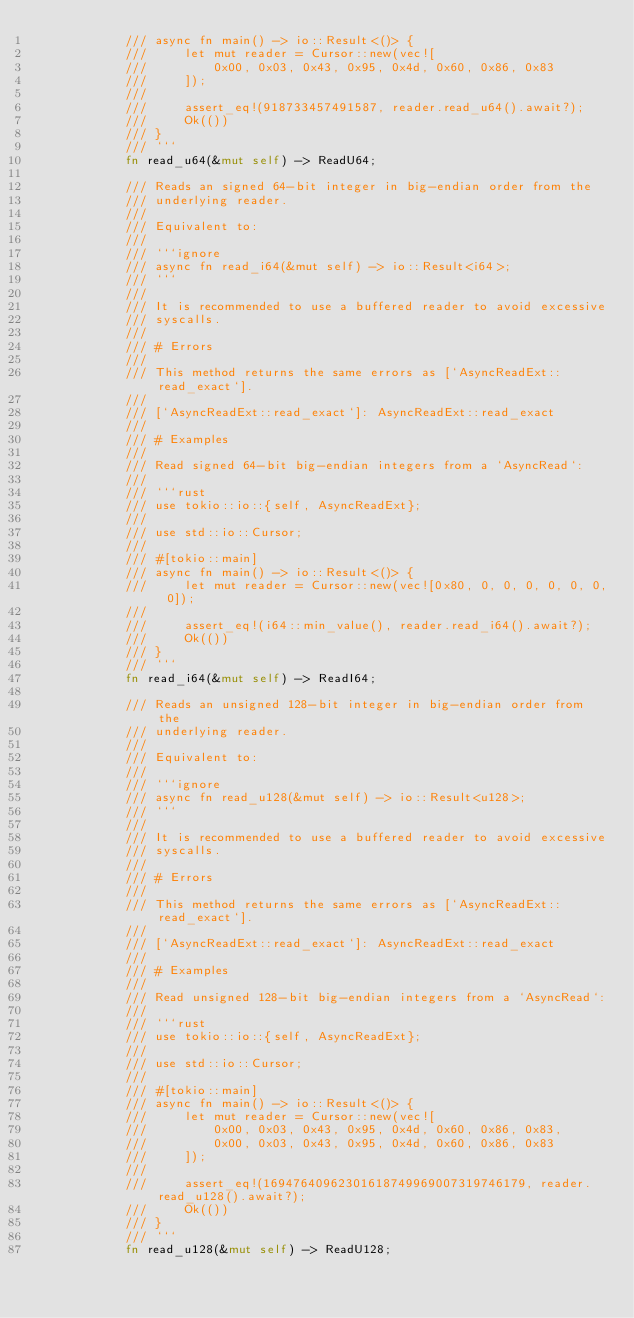Convert code to text. <code><loc_0><loc_0><loc_500><loc_500><_Rust_>            /// async fn main() -> io::Result<()> {
            ///     let mut reader = Cursor::new(vec![
            ///         0x00, 0x03, 0x43, 0x95, 0x4d, 0x60, 0x86, 0x83
            ///     ]);
            ///
            ///     assert_eq!(918733457491587, reader.read_u64().await?);
            ///     Ok(())
            /// }
            /// ```
            fn read_u64(&mut self) -> ReadU64;

            /// Reads an signed 64-bit integer in big-endian order from the
            /// underlying reader.
            ///
            /// Equivalent to:
            ///
            /// ```ignore
            /// async fn read_i64(&mut self) -> io::Result<i64>;
            /// ```
            ///
            /// It is recommended to use a buffered reader to avoid excessive
            /// syscalls.
            ///
            /// # Errors
            ///
            /// This method returns the same errors as [`AsyncReadExt::read_exact`].
            ///
            /// [`AsyncReadExt::read_exact`]: AsyncReadExt::read_exact
            ///
            /// # Examples
            ///
            /// Read signed 64-bit big-endian integers from a `AsyncRead`:
            ///
            /// ```rust
            /// use tokio::io::{self, AsyncReadExt};
            ///
            /// use std::io::Cursor;
            ///
            /// #[tokio::main]
            /// async fn main() -> io::Result<()> {
            ///     let mut reader = Cursor::new(vec![0x80, 0, 0, 0, 0, 0, 0, 0]);
            ///
            ///     assert_eq!(i64::min_value(), reader.read_i64().await?);
            ///     Ok(())
            /// }
            /// ```
            fn read_i64(&mut self) -> ReadI64;

            /// Reads an unsigned 128-bit integer in big-endian order from the
            /// underlying reader.
            ///
            /// Equivalent to:
            ///
            /// ```ignore
            /// async fn read_u128(&mut self) -> io::Result<u128>;
            /// ```
            ///
            /// It is recommended to use a buffered reader to avoid excessive
            /// syscalls.
            ///
            /// # Errors
            ///
            /// This method returns the same errors as [`AsyncReadExt::read_exact`].
            ///
            /// [`AsyncReadExt::read_exact`]: AsyncReadExt::read_exact
            ///
            /// # Examples
            ///
            /// Read unsigned 128-bit big-endian integers from a `AsyncRead`:
            ///
            /// ```rust
            /// use tokio::io::{self, AsyncReadExt};
            ///
            /// use std::io::Cursor;
            ///
            /// #[tokio::main]
            /// async fn main() -> io::Result<()> {
            ///     let mut reader = Cursor::new(vec![
            ///         0x00, 0x03, 0x43, 0x95, 0x4d, 0x60, 0x86, 0x83,
            ///         0x00, 0x03, 0x43, 0x95, 0x4d, 0x60, 0x86, 0x83
            ///     ]);
            ///
            ///     assert_eq!(16947640962301618749969007319746179, reader.read_u128().await?);
            ///     Ok(())
            /// }
            /// ```
            fn read_u128(&mut self) -> ReadU128;
</code> 